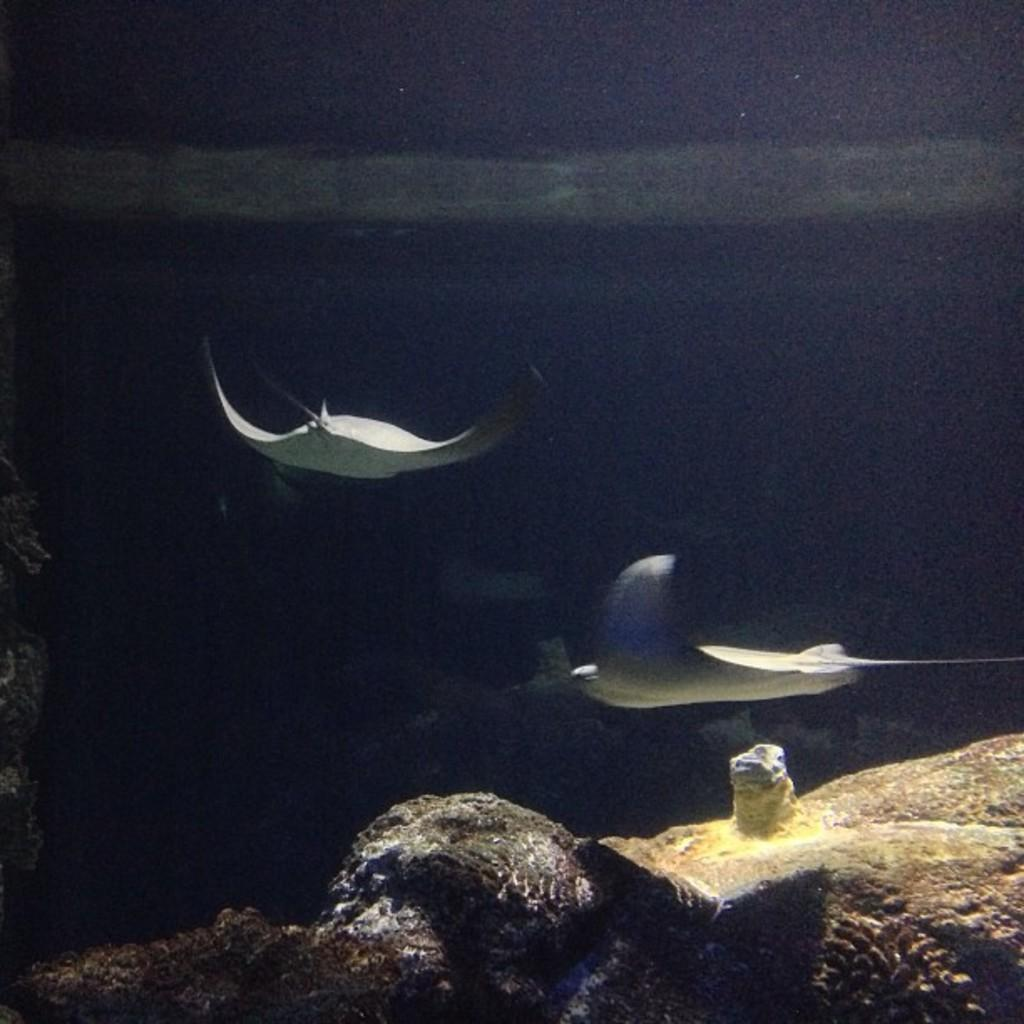What is the setting of the image? The image is taken underwater. What type of marine animals can be seen in the image? There are stingrays swimming in the water. What is visible at the bottom of the image? There are rocks at the bottom of the image. How would you describe the lighting in the image? The background of the image is dark. What type of bird can be seen drinking milk in the image? There is no bird or milk present in the image; it is taken underwater and features stingrays swimming. Is there any payment being made in the image? There is no payment being made in the image; it is a photograph of stingrays swimming underwater. 